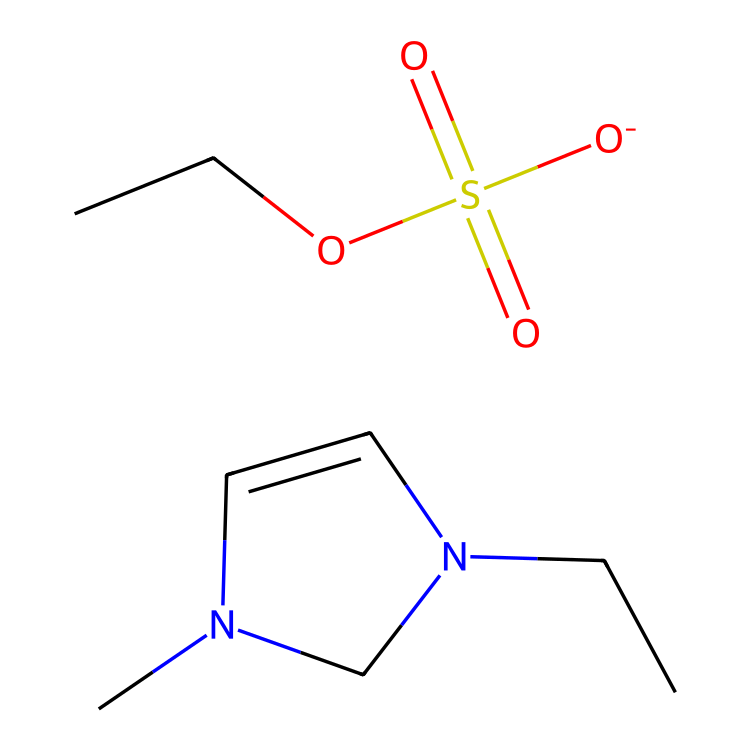What is the total number of carbon atoms in the structure? By examining the SMILES notation, CCN1C=CN(C)C1.[O-]S(=O)(=O)OCC, we can count the carbon atoms represented by 'C' and the branches. There are 7 carbon atoms in total.
Answer: seven What type of bonding is primarily present in this ionic liquid? The structure indicates ionic bonding due to the presence of charged species (the imidazolium cation and the ethylsulfate anion) and the connectivity of the nitrogen, oxygen, and sulfur atoms.
Answer: ionic How many nitrogen atoms are in the compound? The notation N shows that there are two nitrogen atoms present in the structure. They can be counted directly from the parentheses in the SMILES.
Answer: two What functional groups are present in this ionic liquid? The presence of a sulfonate group (from the ethylsulfate) and the imidazolium group indicates that the compound contains a sulfonate and an imidazole functional group.
Answer: sulfonate and imidazole Which part of the structure contributes to its ability to act as a sound-absorbing material? The large and complex ionic structure along with the sulfonate moiety enhances the viscosity and low volatility which are important properties for sound absorption.
Answer: ionic structure What is the oxidation state of sulfur in the sulfate group? In the ethylsulfate part of the structure, sulfur typically has an oxidation state of +6 due to its bonding with four oxygen atoms in the sulfonic structure.
Answer: six 